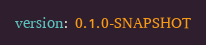Convert code to text. <code><loc_0><loc_0><loc_500><loc_500><_YAML_>version: 0.1.0-SNAPSHOT
</code> 